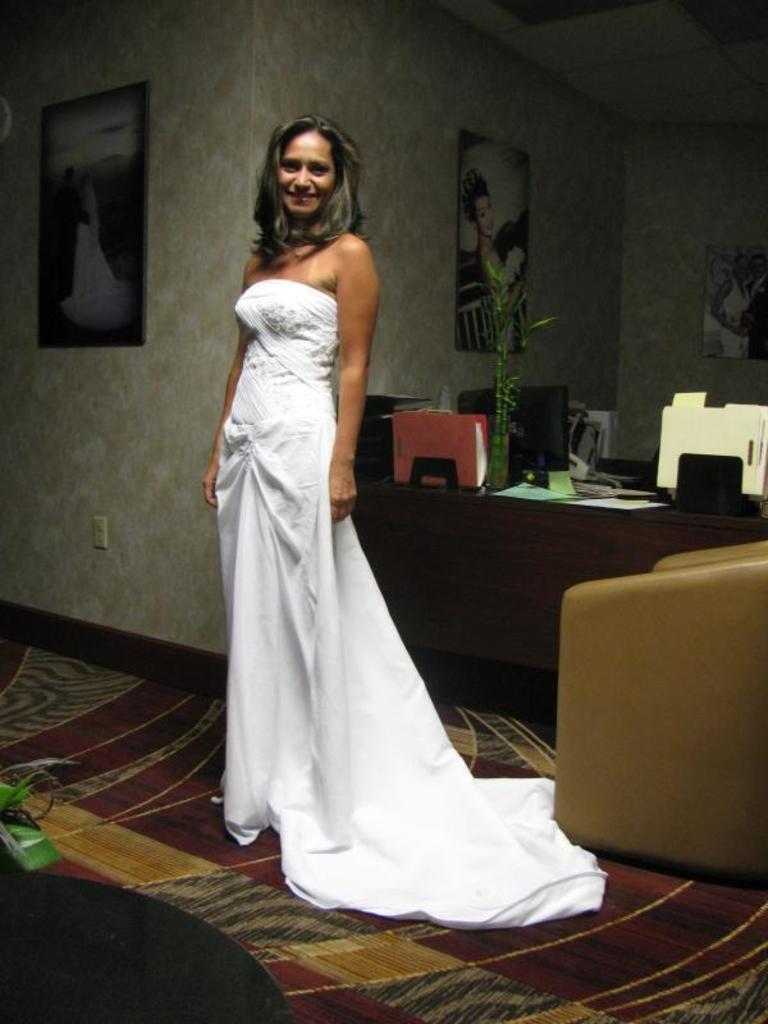Can you describe this image briefly? This picture is of inside the room. On the right corner we can see a chair and a carpet. In the center there is a woman standing, wearing white color dress and smiling, behind her there is a table on the top of which some papers and a monitor and some other items are placed. In the background we can see a wall and picture frames hanging on a wall. 